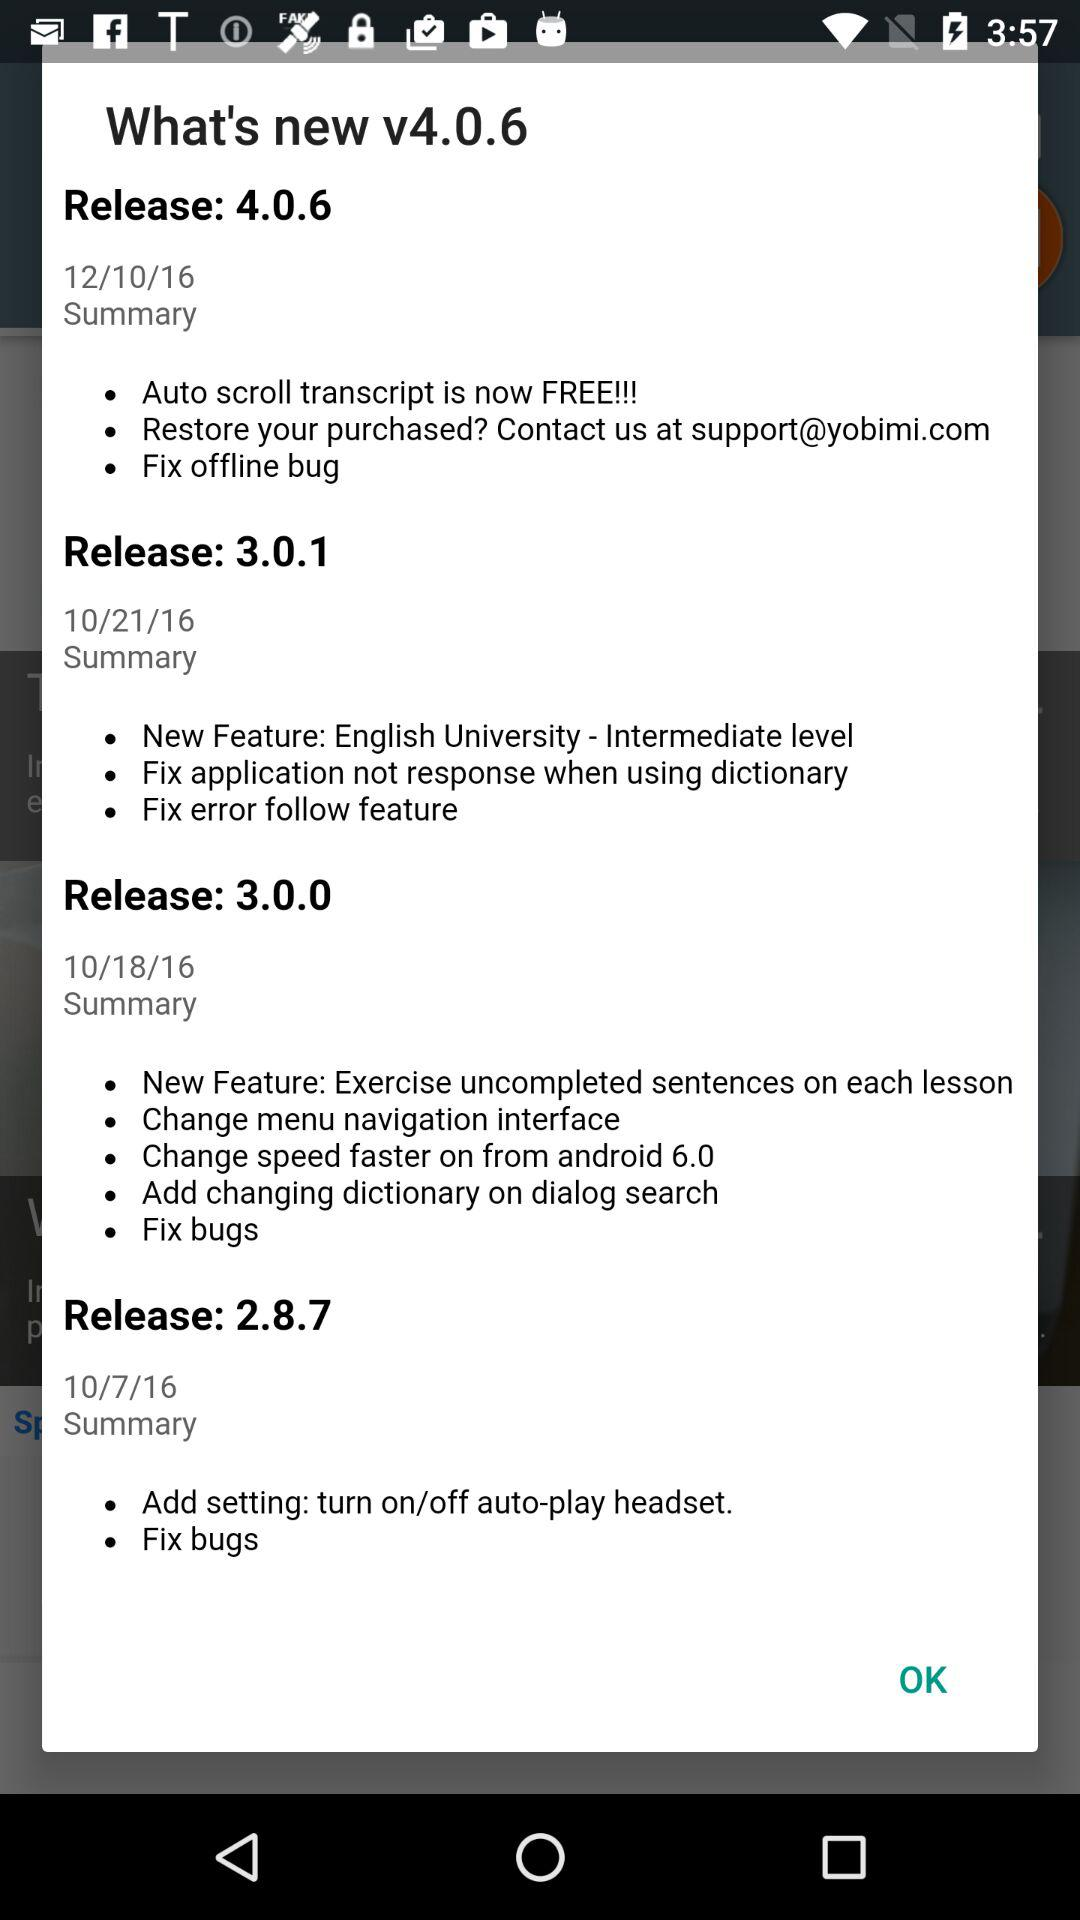What is the date of the new release? The date is 12/10/16. 